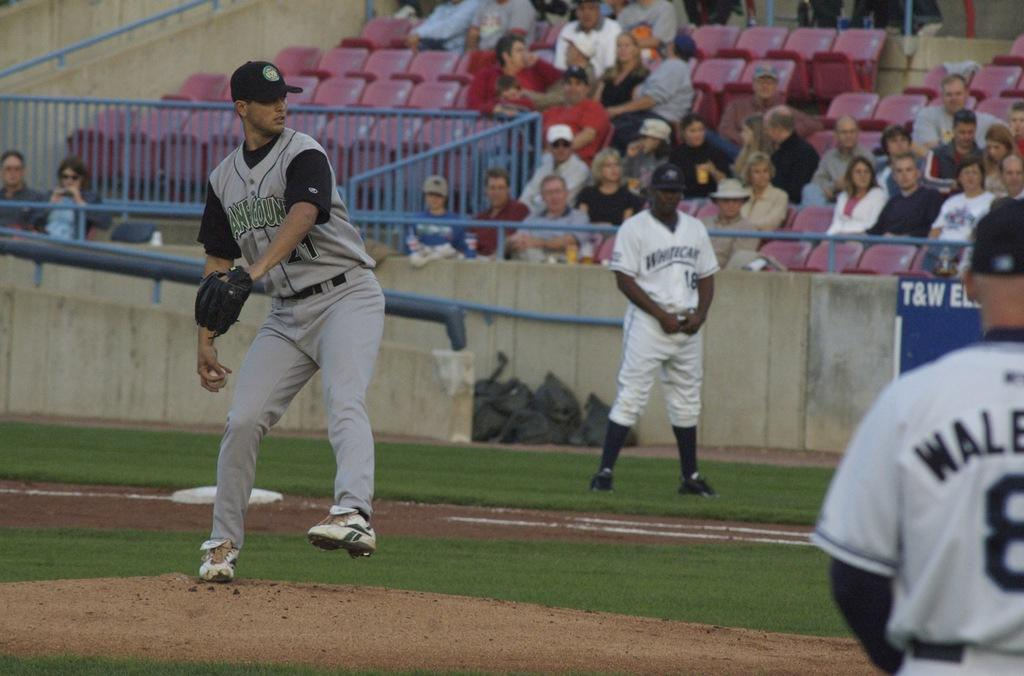<image>
Give a short and clear explanation of the subsequent image. A baseball game is underway and one of the player's uniforms says Whiticar. 